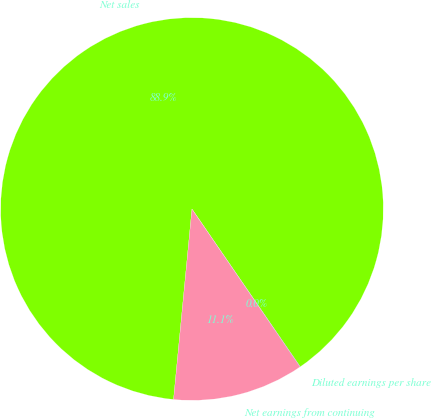Convert chart. <chart><loc_0><loc_0><loc_500><loc_500><pie_chart><fcel>Net sales<fcel>Net earnings from continuing<fcel>Diluted earnings per share<nl><fcel>88.89%<fcel>11.09%<fcel>0.02%<nl></chart> 